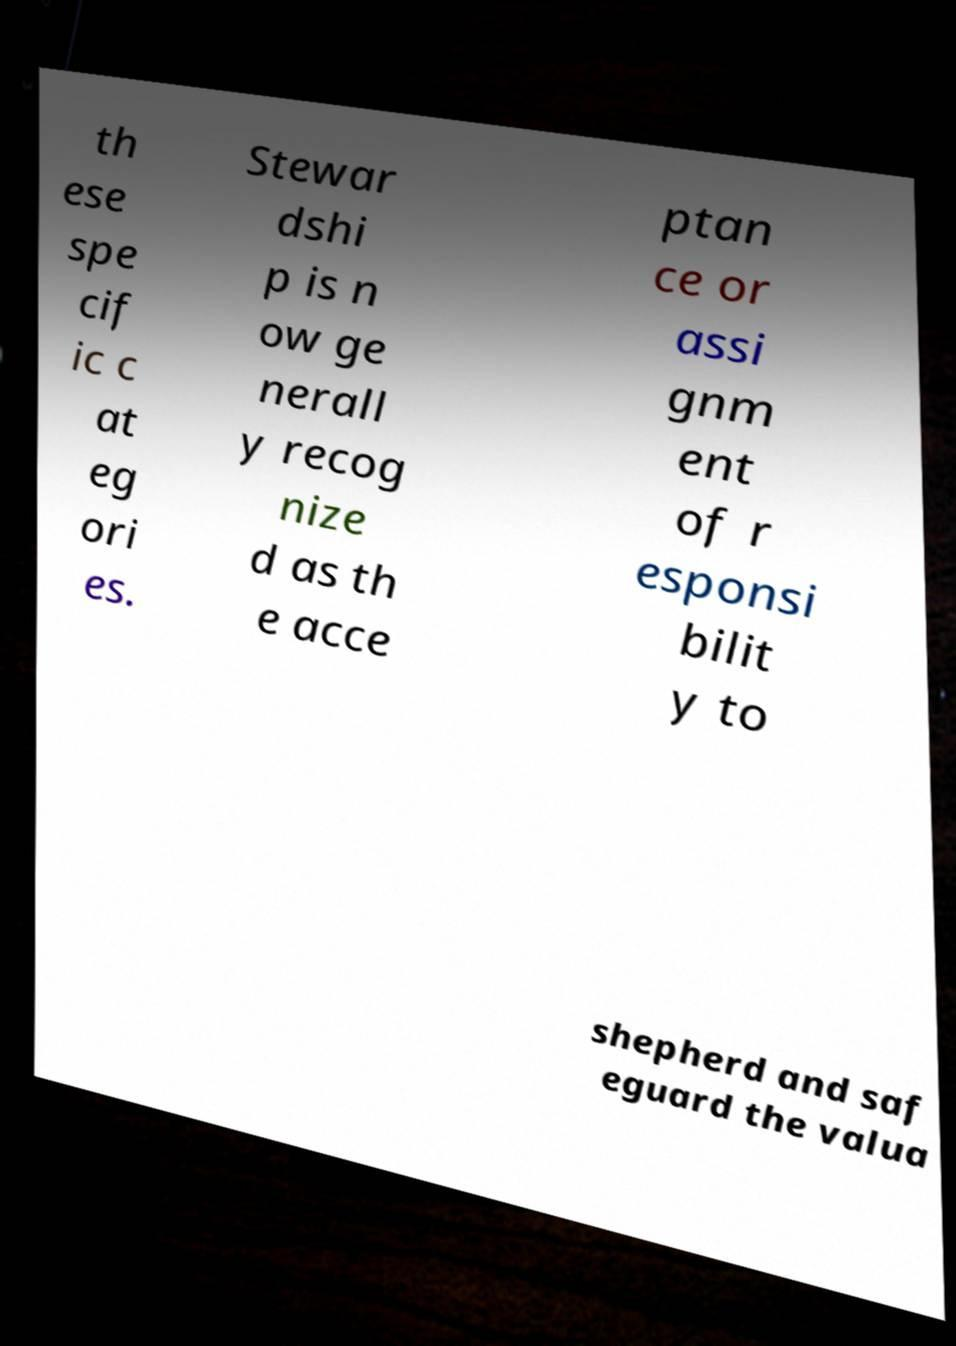Could you assist in decoding the text presented in this image and type it out clearly? th ese spe cif ic c at eg ori es. Stewar dshi p is n ow ge nerall y recog nize d as th e acce ptan ce or assi gnm ent of r esponsi bilit y to shepherd and saf eguard the valua 